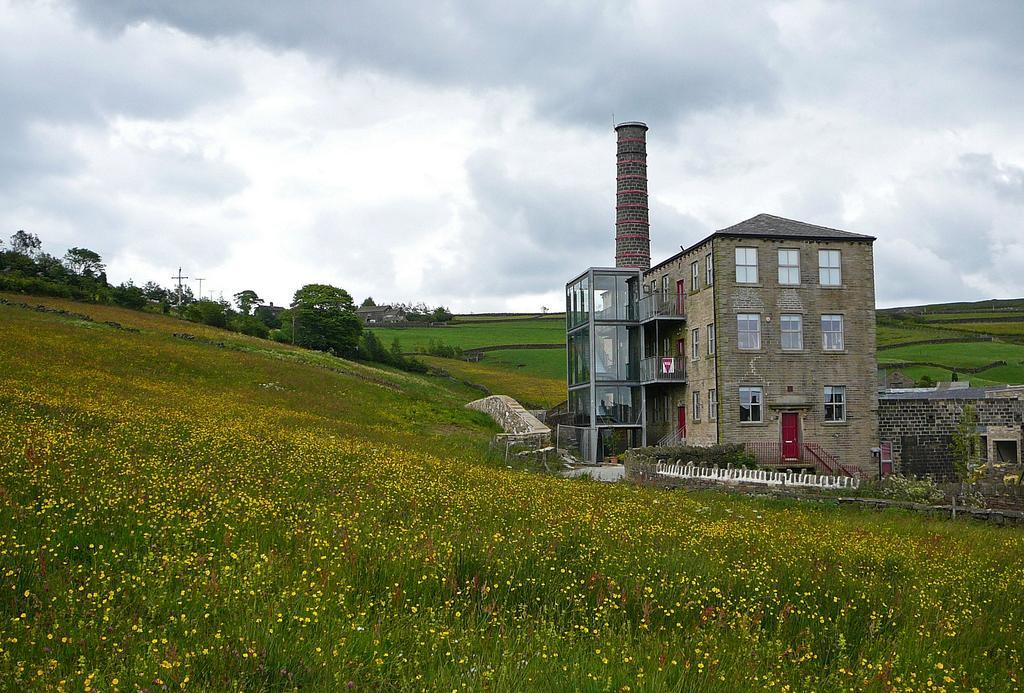Can you describe this image briefly? Here we can see plants with flowers. Background there is a building, fence, plants, trees, poles, tower, grass and sky. Sky is cloudy. To this building there are glass windows and door. 